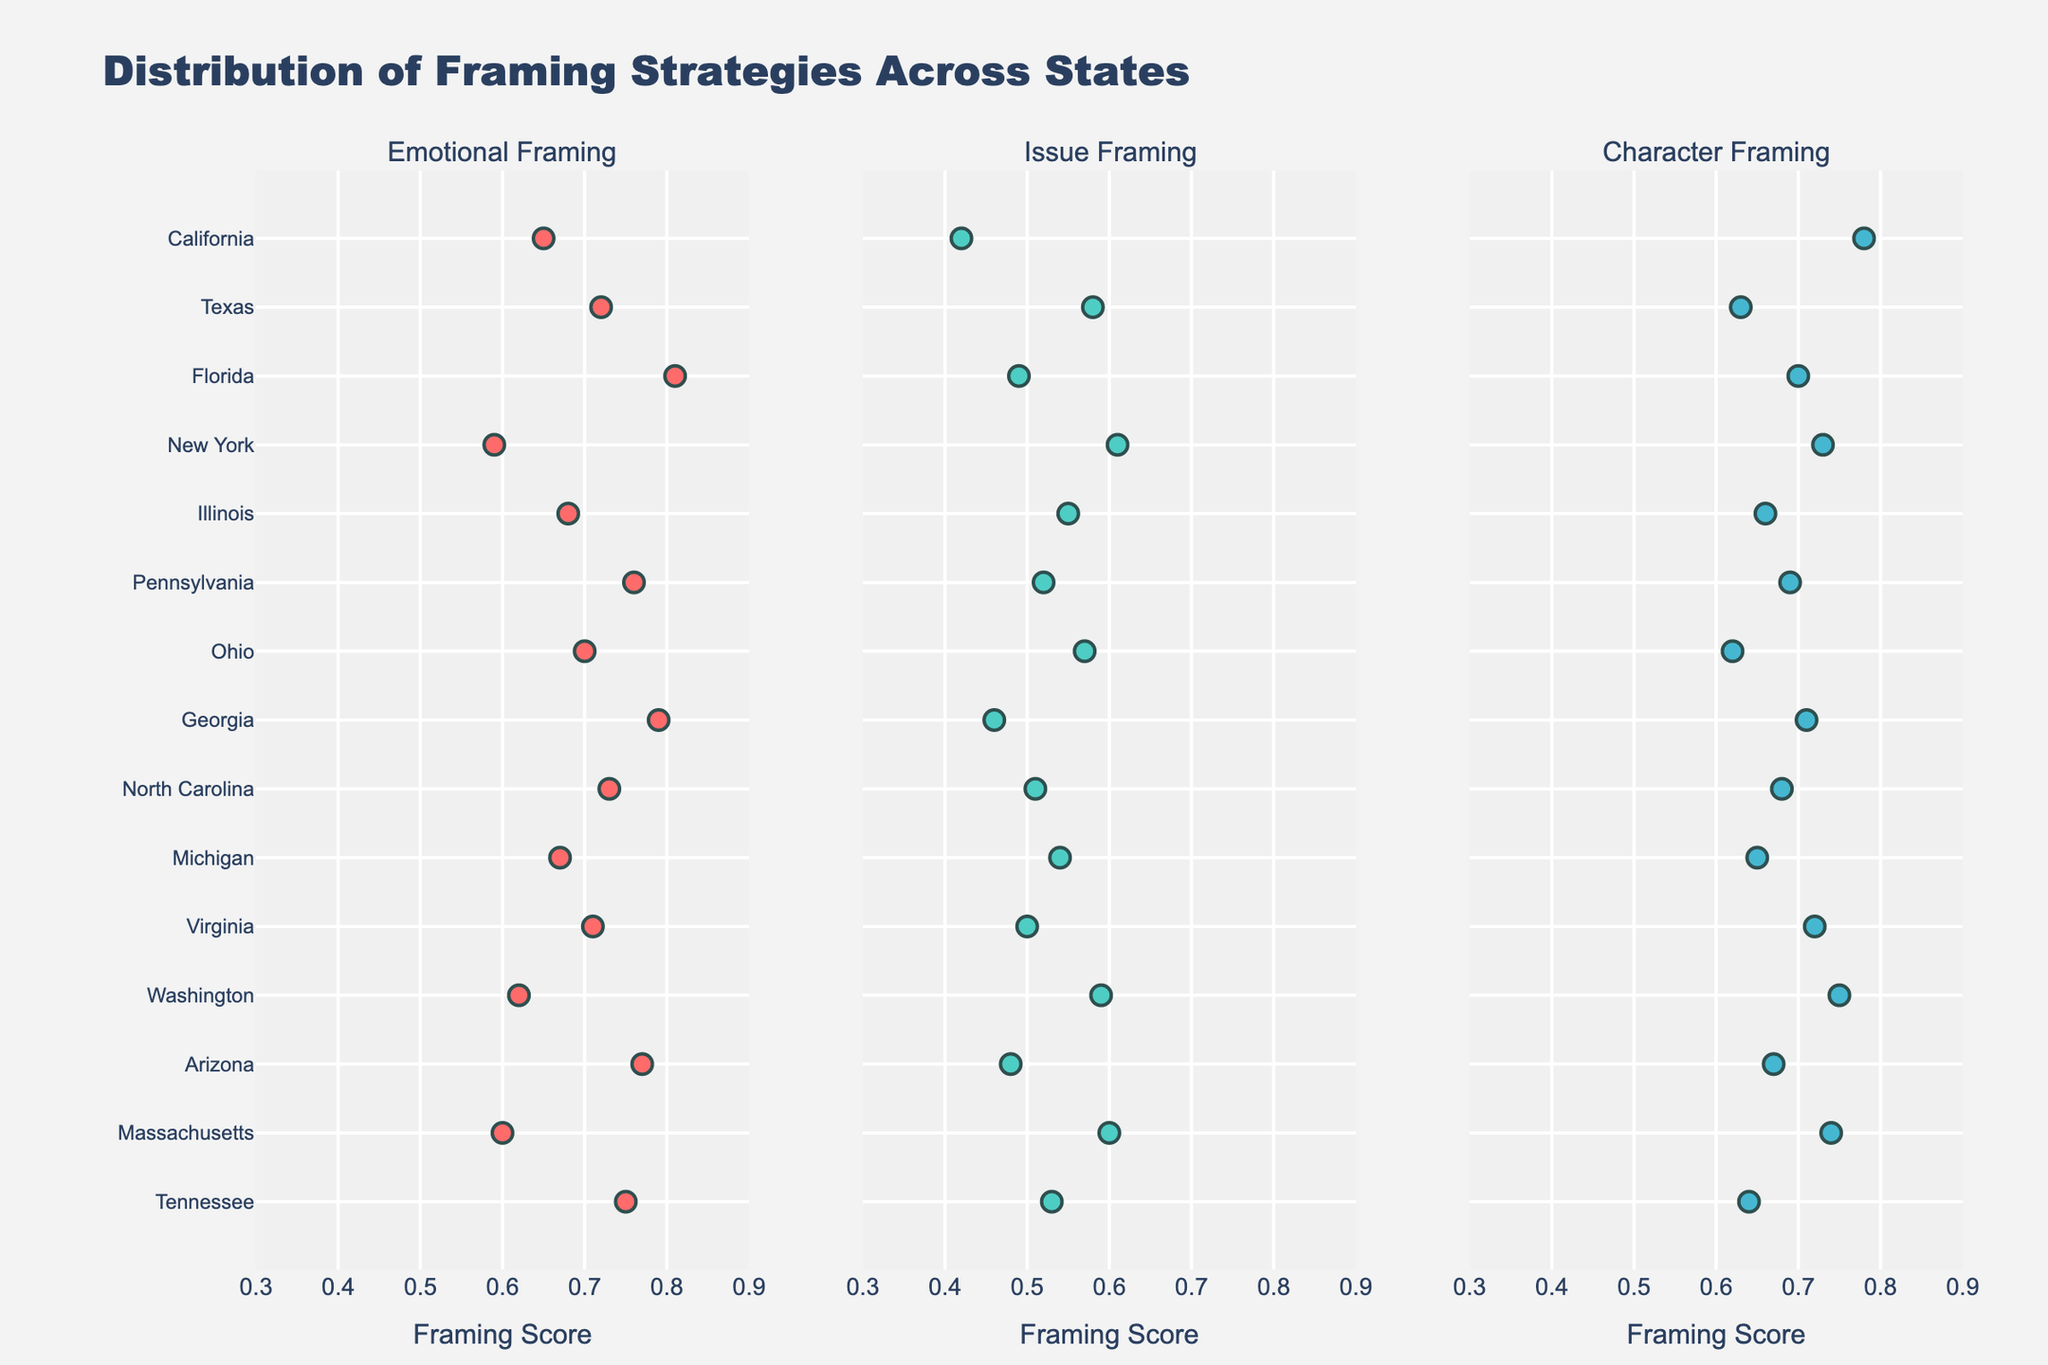What is the title of the figure? The title of the figure is written at the top of the plot and provides a quick summary of what the plot represents.
Answer: Distribution of Framing Strategies Across States What is the range of the x-axis in the figure? The x-axis range is determined by the minimum and maximum values displayed along the axis for framing scores, which are between 0.3 and 0.9.
Answer: 0.3 to 0.9 Which state shows the highest score in Emotional Framing? The state with the highest score in the Emotional Framing subplot is indicated by the highest positioning of a marker along the x-axis in the Emotional Framing subplot.
Answer: Florida How does the score for Character Framing in New York compare to that in Virginia? By examining the subplot for Character Framing, we compare the x-axis values of New York and Virginia, noting the relative positioning of their markers.
Answer: New York is lower than Virginia What can be said about the Issue Framing score range across all states? By observing the Issue Framing subplot, we can identify the minimum and maximum x-axis values and describe the spread of the scores across states.
Answer: The scores range from 0.42 to 0.61 Which framing strategy has the most consistent scores across the states? To determine consistency, we compare the spread and clustering of markers within each subplot, identifying the subplot with the smallest range of x-axis values.
Answer: Issue Framing Identify the states with a Character Framing score greater than 0.75. In the Character Framing subplot, the states with scores greater than 0.75 are those whose markers fall to the right of the 0.75 x-axis value.
Answer: California, Washington, Massachusetts How many states have an Emotional Framing score above 0.75? By counting the markers in the Emotional Framing subplot that fall to the right of the 0.75 x-axis value, we can determine the number of states.
Answer: 6 Which state has the lowest Issue Framing score, and what is that score? By examining the Issue Framing subplot and identifying the state with the leftmost marker, we can find the state with the lowest score and its value.
Answer: California, 0.42 Compare the Emotional Framing scores for Texas and Ohio. Which state has the higher score? By locating the markers for Texas and Ohio in the Emotional Framing subplot and comparing their positions along the x-axis, we can determine which state has the higher score.
Answer: Texas 